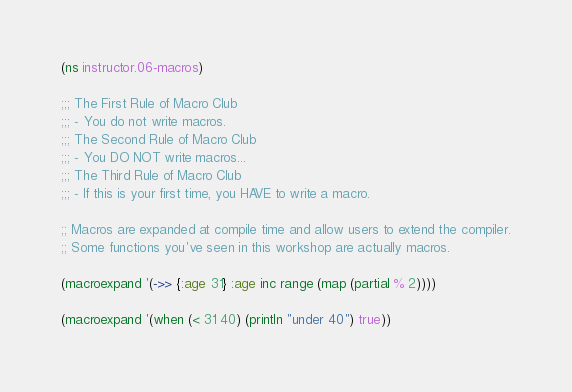Convert code to text. <code><loc_0><loc_0><loc_500><loc_500><_Clojure_>(ns instructor.06-macros)

;;; The First Rule of Macro Club
;;; - You do not write macros.
;;; The Second Rule of Macro Club
;;; - You DO NOT write macros...
;;; The Third Rule of Macro Club
;;; - If this is your first time, you HAVE to write a macro.

;; Macros are expanded at compile time and allow users to extend the compiler.
;; Some functions you've seen in this workshop are actually macros.

(macroexpand '(->> {:age 31} :age inc range (map (partial % 2))))

(macroexpand '(when (< 31 40) (println "under 40") true))
</code> 